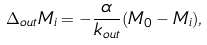<formula> <loc_0><loc_0><loc_500><loc_500>\Delta _ { o u t } M _ { i } = - \frac { \alpha } { k _ { o u t } } ( M _ { 0 } - M _ { i } ) ,</formula> 